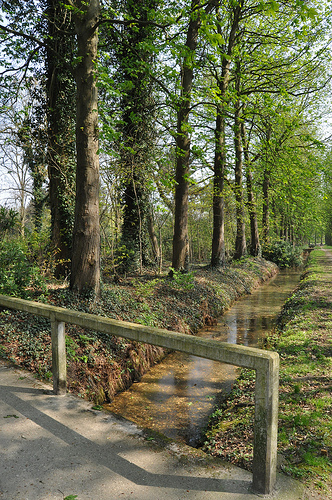<image>
Is the road under the water? No. The road is not positioned under the water. The vertical relationship between these objects is different. 